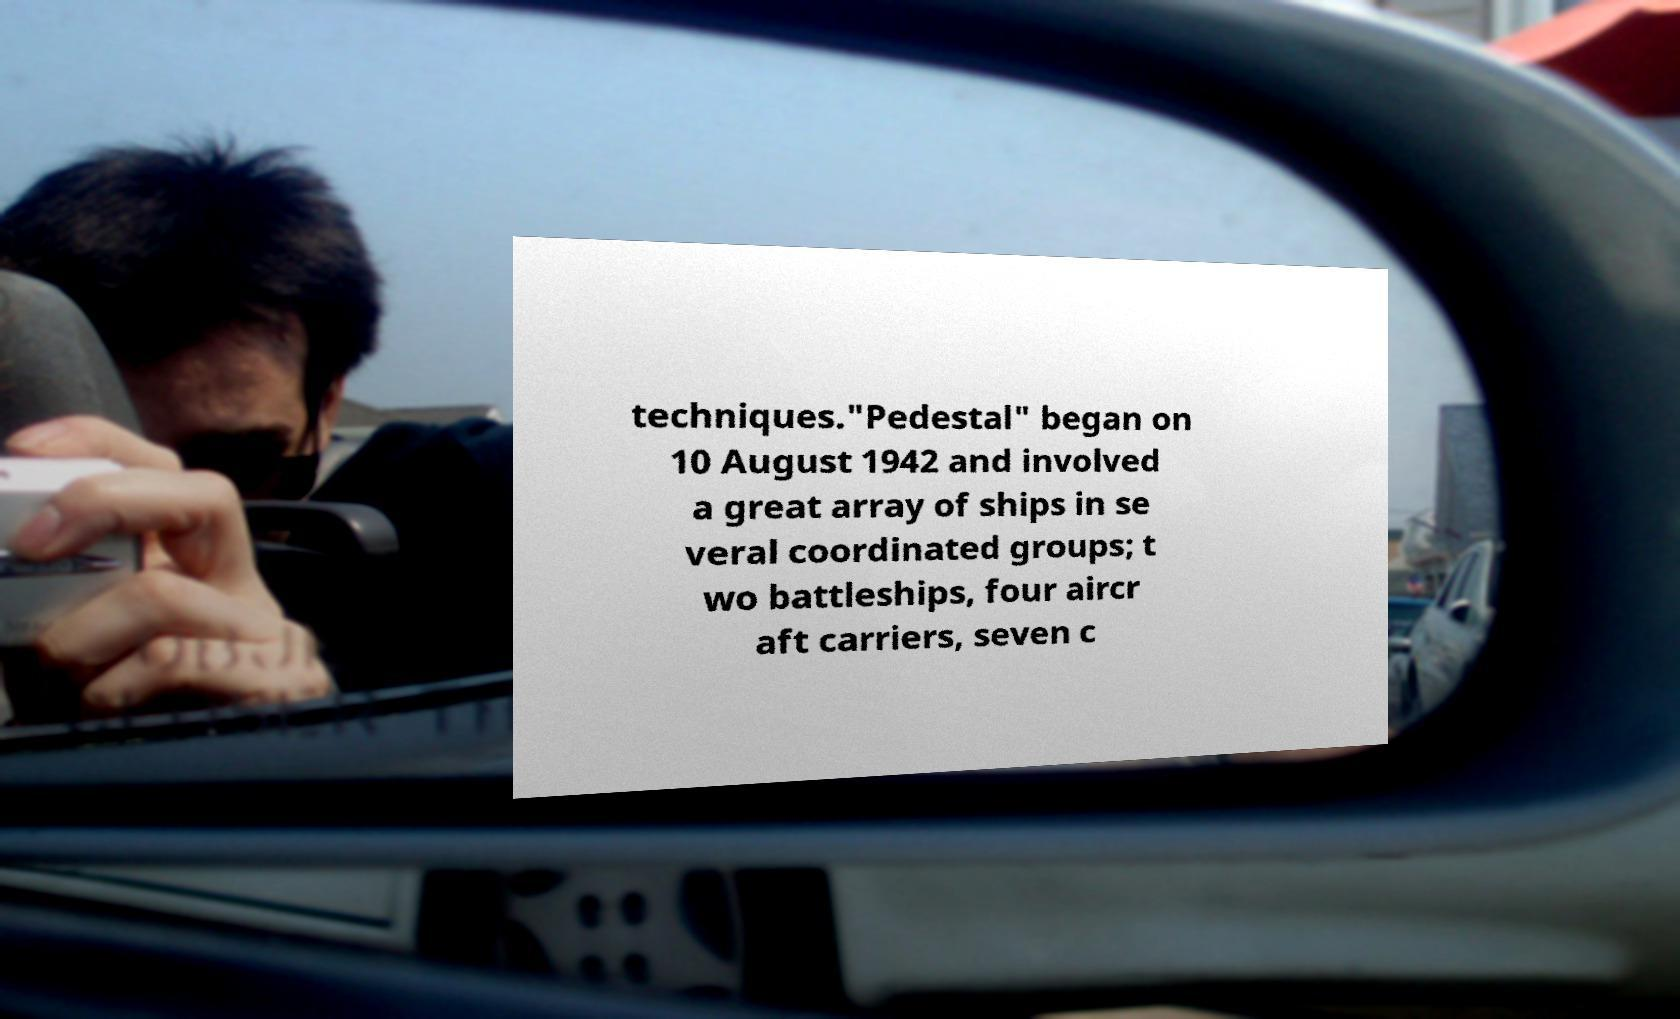I need the written content from this picture converted into text. Can you do that? techniques."Pedestal" began on 10 August 1942 and involved a great array of ships in se veral coordinated groups; t wo battleships, four aircr aft carriers, seven c 